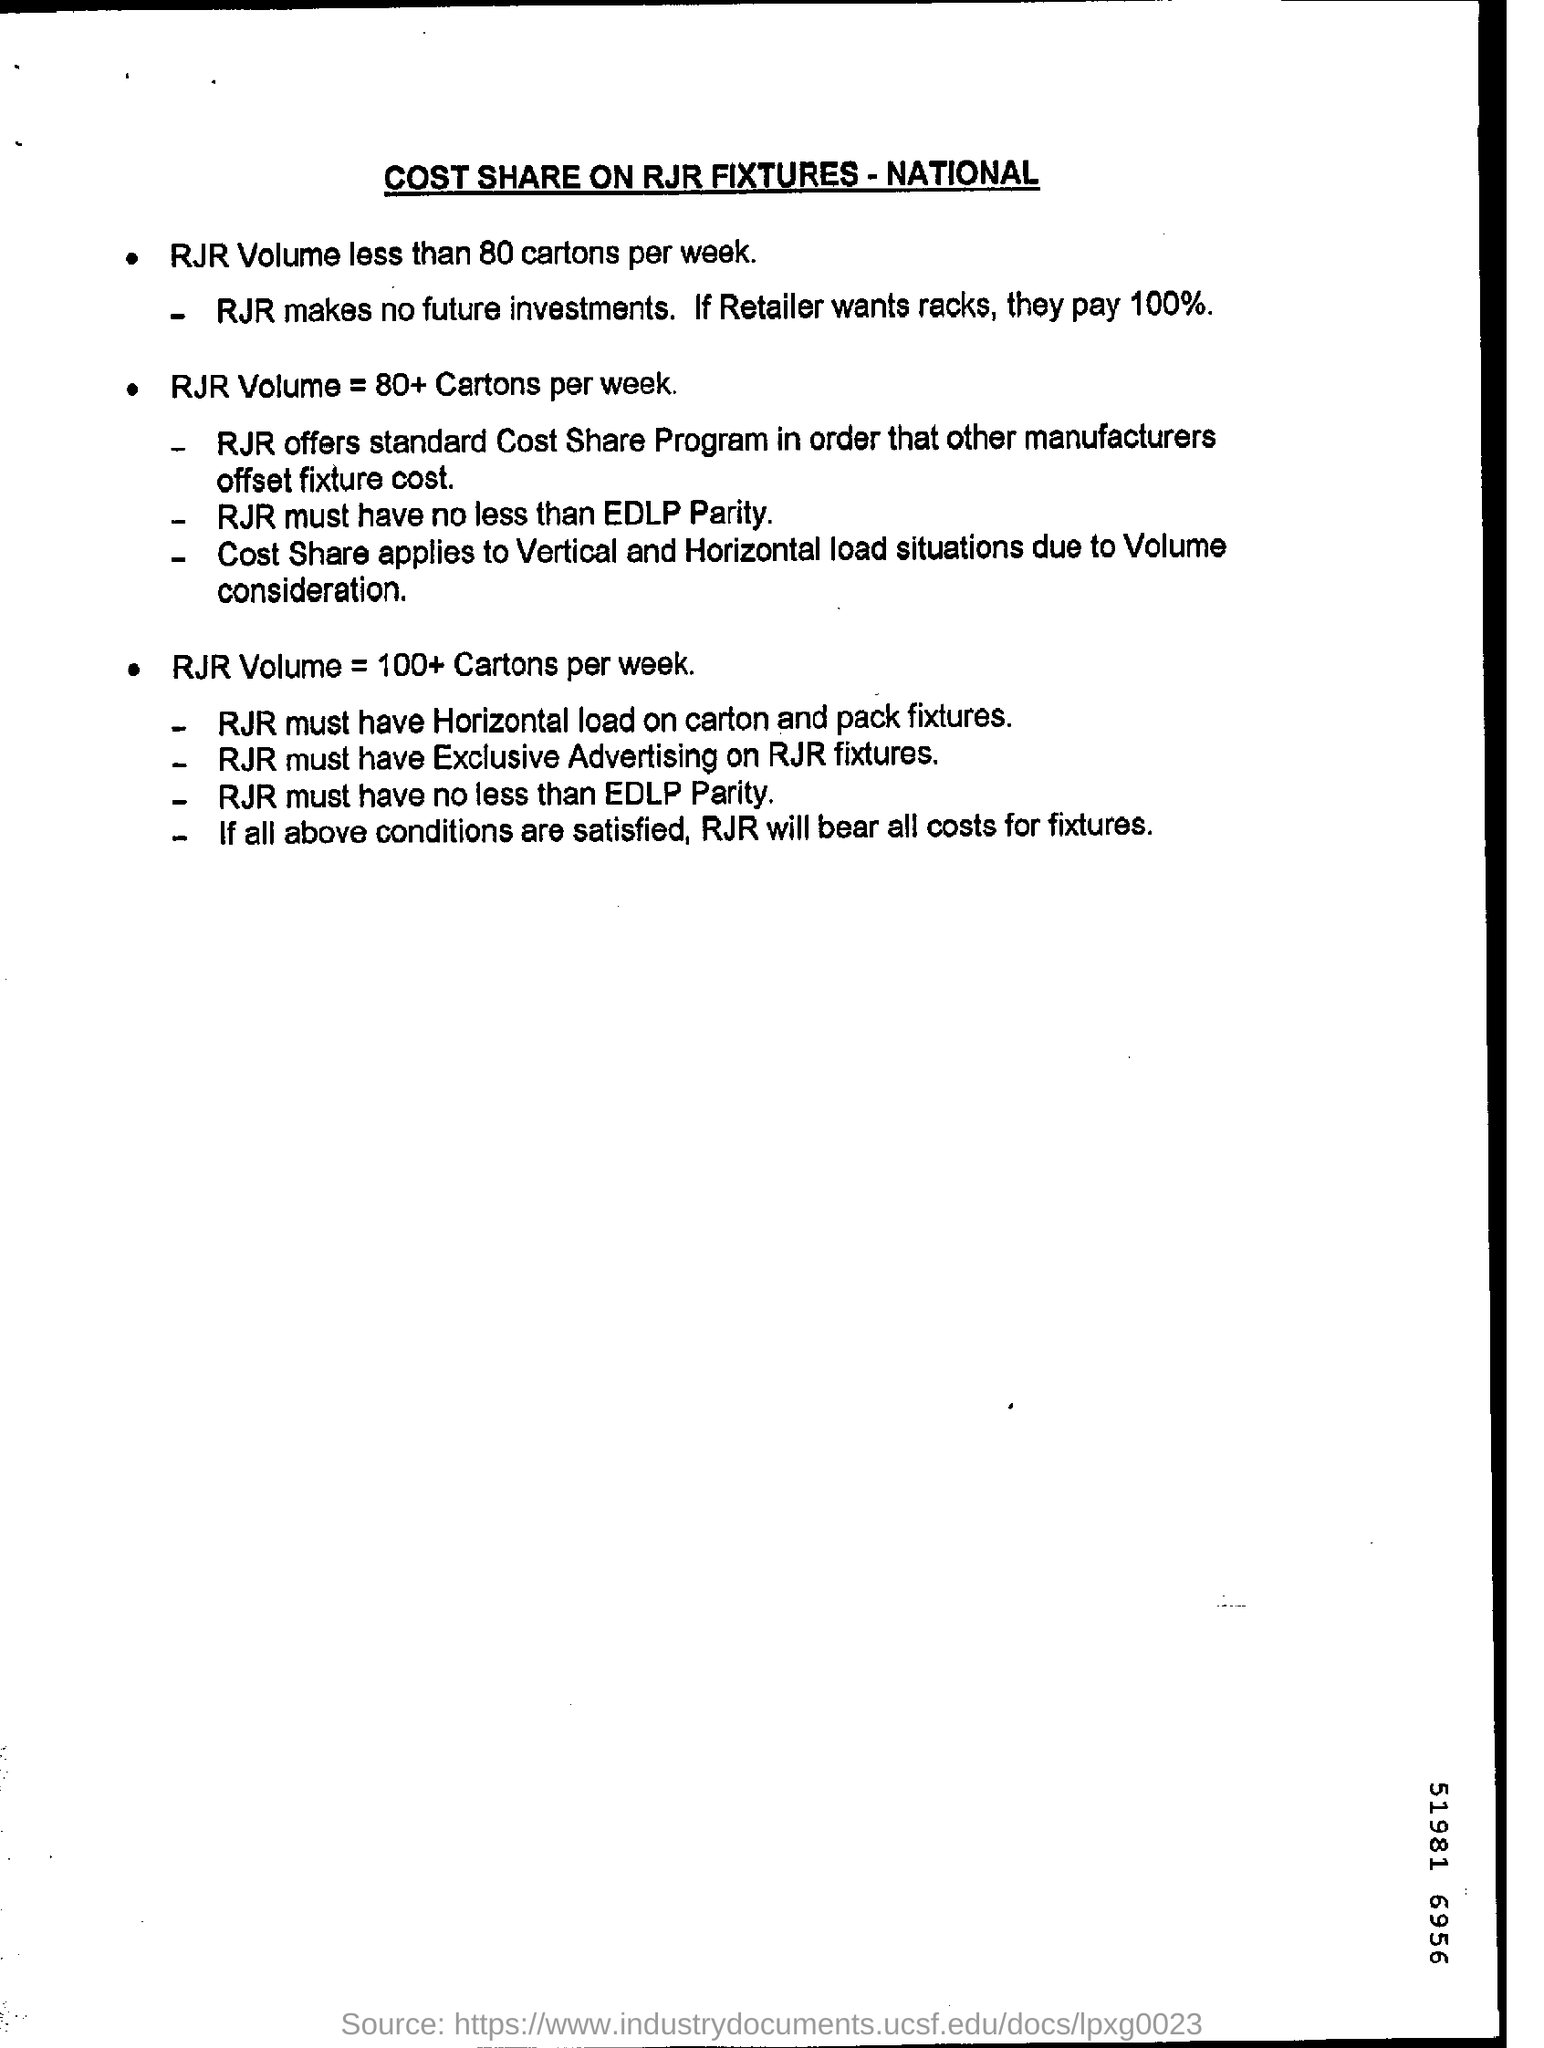Point out several critical features in this image. If a retailer wants to use racks, they will have to pay 100% of the cost. 